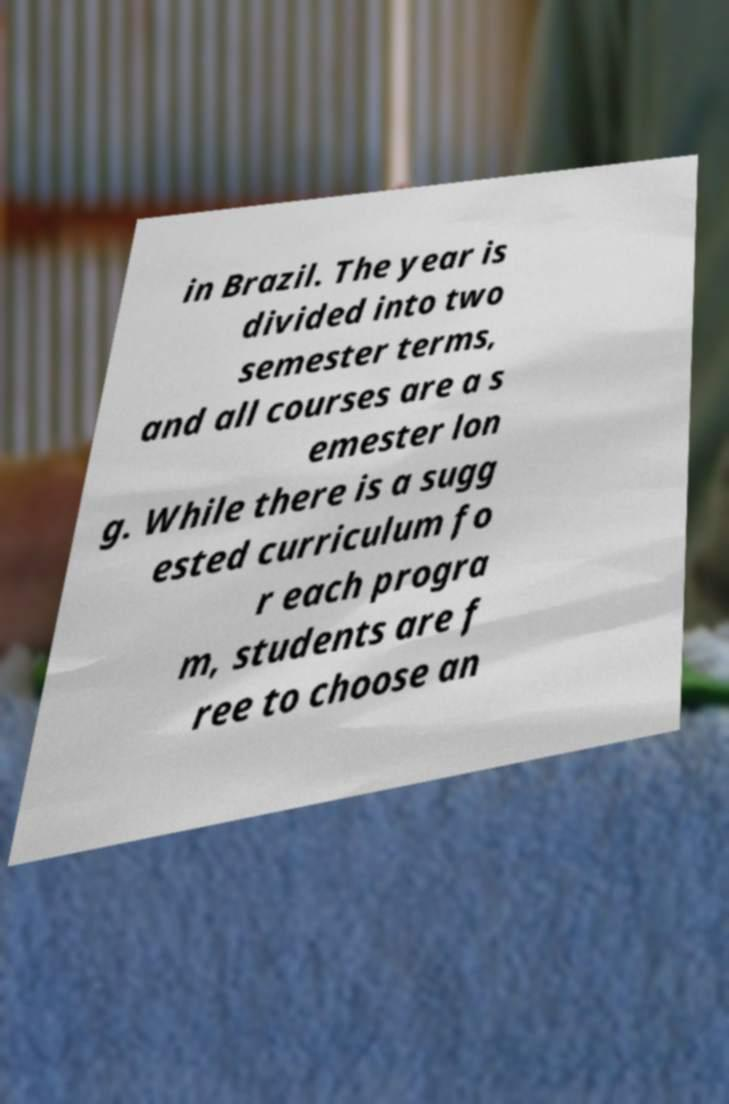For documentation purposes, I need the text within this image transcribed. Could you provide that? in Brazil. The year is divided into two semester terms, and all courses are a s emester lon g. While there is a sugg ested curriculum fo r each progra m, students are f ree to choose an 